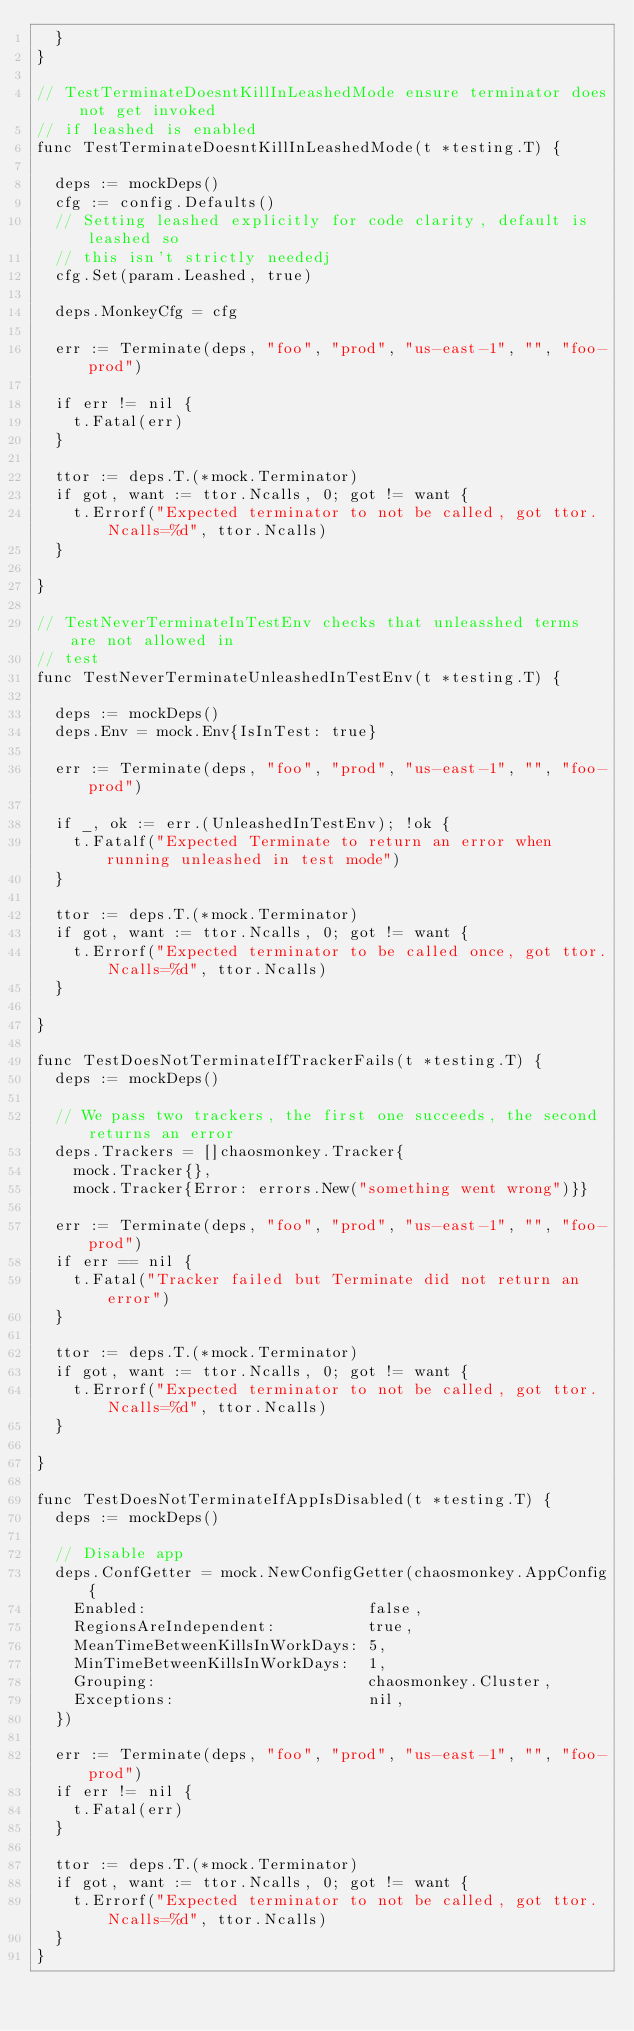<code> <loc_0><loc_0><loc_500><loc_500><_Go_>	}
}

// TestTerminateDoesntKillInLeashedMode ensure terminator does not get invoked
// if leashed is enabled
func TestTerminateDoesntKillInLeashedMode(t *testing.T) {

	deps := mockDeps()
	cfg := config.Defaults()
	// Setting leashed explicitly for code clarity, default is leashed so
	// this isn't strictly neededj
	cfg.Set(param.Leashed, true)

	deps.MonkeyCfg = cfg

	err := Terminate(deps, "foo", "prod", "us-east-1", "", "foo-prod")

	if err != nil {
		t.Fatal(err)
	}

	ttor := deps.T.(*mock.Terminator)
	if got, want := ttor.Ncalls, 0; got != want {
		t.Errorf("Expected terminator to not be called, got ttor.Ncalls=%d", ttor.Ncalls)
	}

}

// TestNeverTerminateInTestEnv checks that unleasshed terms are not allowed in
// test
func TestNeverTerminateUnleashedInTestEnv(t *testing.T) {

	deps := mockDeps()
	deps.Env = mock.Env{IsInTest: true}

	err := Terminate(deps, "foo", "prod", "us-east-1", "", "foo-prod")

	if _, ok := err.(UnleashedInTestEnv); !ok {
		t.Fatalf("Expected Terminate to return an error when running unleashed in test mode")
	}

	ttor := deps.T.(*mock.Terminator)
	if got, want := ttor.Ncalls, 0; got != want {
		t.Errorf("Expected terminator to be called once, got ttor.Ncalls=%d", ttor.Ncalls)
	}

}

func TestDoesNotTerminateIfTrackerFails(t *testing.T) {
	deps := mockDeps()

	// We pass two trackers, the first one succeeds, the second returns an error
	deps.Trackers = []chaosmonkey.Tracker{
		mock.Tracker{},
		mock.Tracker{Error: errors.New("something went wrong")}}

	err := Terminate(deps, "foo", "prod", "us-east-1", "", "foo-prod")
	if err == nil {
		t.Fatal("Tracker failed but Terminate did not return an error")
	}

	ttor := deps.T.(*mock.Terminator)
	if got, want := ttor.Ncalls, 0; got != want {
		t.Errorf("Expected terminator to not be called, got ttor.Ncalls=%d", ttor.Ncalls)
	}

}

func TestDoesNotTerminateIfAppIsDisabled(t *testing.T) {
	deps := mockDeps()

	// Disable app
	deps.ConfGetter = mock.NewConfigGetter(chaosmonkey.AppConfig{
		Enabled:                        false,
		RegionsAreIndependent:          true,
		MeanTimeBetweenKillsInWorkDays: 5,
		MinTimeBetweenKillsInWorkDays:  1,
		Grouping:                       chaosmonkey.Cluster,
		Exceptions:                     nil,
	})

	err := Terminate(deps, "foo", "prod", "us-east-1", "", "foo-prod")
	if err != nil {
		t.Fatal(err)
	}

	ttor := deps.T.(*mock.Terminator)
	if got, want := ttor.Ncalls, 0; got != want {
		t.Errorf("Expected terminator to not be called, got ttor.Ncalls=%d", ttor.Ncalls)
	}
}
</code> 